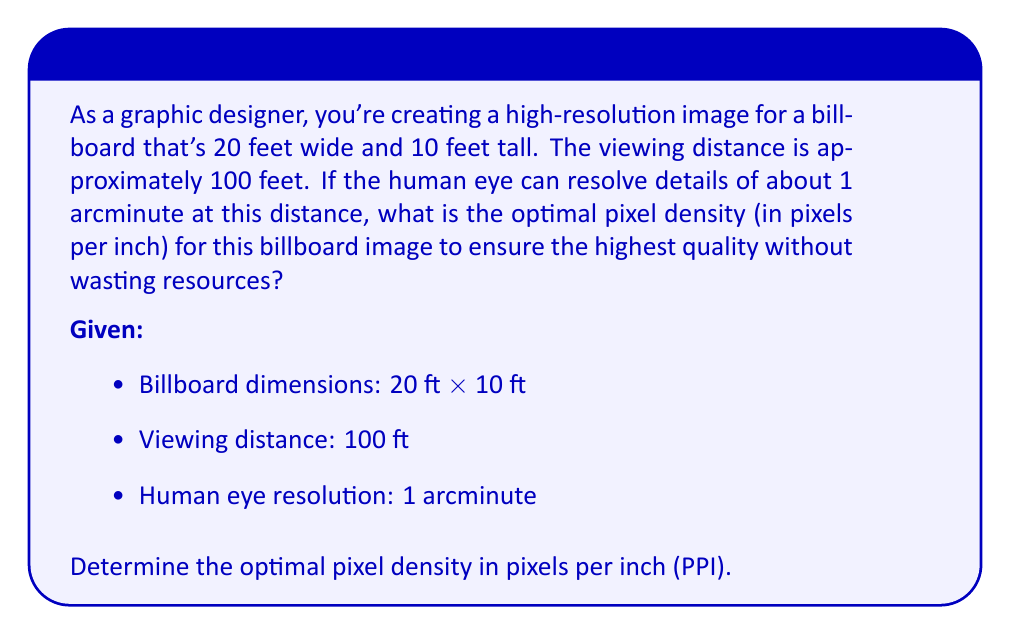Give your solution to this math problem. Let's approach this step-by-step:

1) First, we need to calculate the angle subtended by 1 inch at 100 feet:
   $$ \tan(\theta) = \frac{1 \text{ inch}}{100 \text{ feet} \times 12 \text{ inches/foot}} $$
   $$ \theta = \arctan(\frac{1}{1200}) \approx 0.0478° $$

2) Convert this angle to arcminutes:
   $$ 0.0478° \times 60 \text{ arcminutes/degree} \approx 2.87 \text{ arcminutes} $$

3) The human eye can resolve 1 arcminute, so we need:
   $$ \frac{2.87 \text{ arcminutes}}{1 \text{ arcminute/pixel}} \approx 2.87 \text{ pixels per inch} $$

4) To ensure the highest quality, we'll round up to 3 pixels per inch.

5) However, common practice in printing is to use at least 300 PPI for high-quality images. Since billboards are viewed from a distance, we can use a lower resolution. A common rule of thumb is to use 1/10 to 1/4 of the standard 300 PPI for large format printing.

6) Let's choose 1/4 of 300 PPI as our optimal density:
   $$ 300 \text{ PPI} \times \frac{1}{4} = 75 \text{ PPI} $$

This density is well above the minimum required for visual acuity at the given distance, ensuring high quality while not wasting resources.
Answer: 75 PPI 